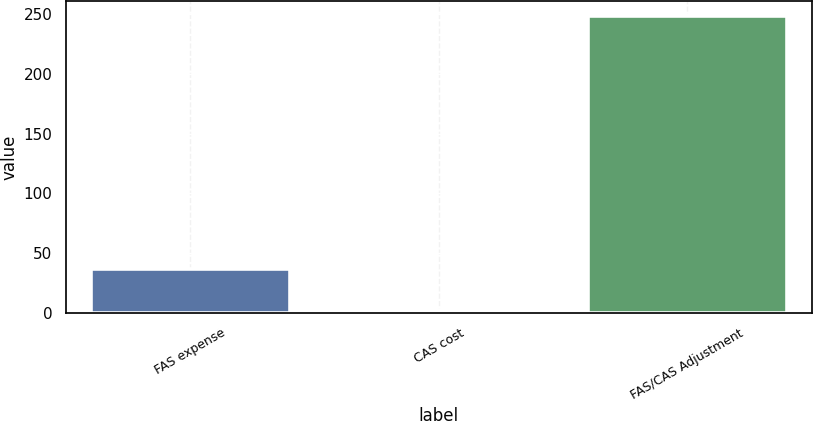Convert chart to OTSL. <chart><loc_0><loc_0><loc_500><loc_500><bar_chart><fcel>FAS expense<fcel>CAS cost<fcel>FAS/CAS Adjustment<nl><fcel>37<fcel>3<fcel>248<nl></chart> 